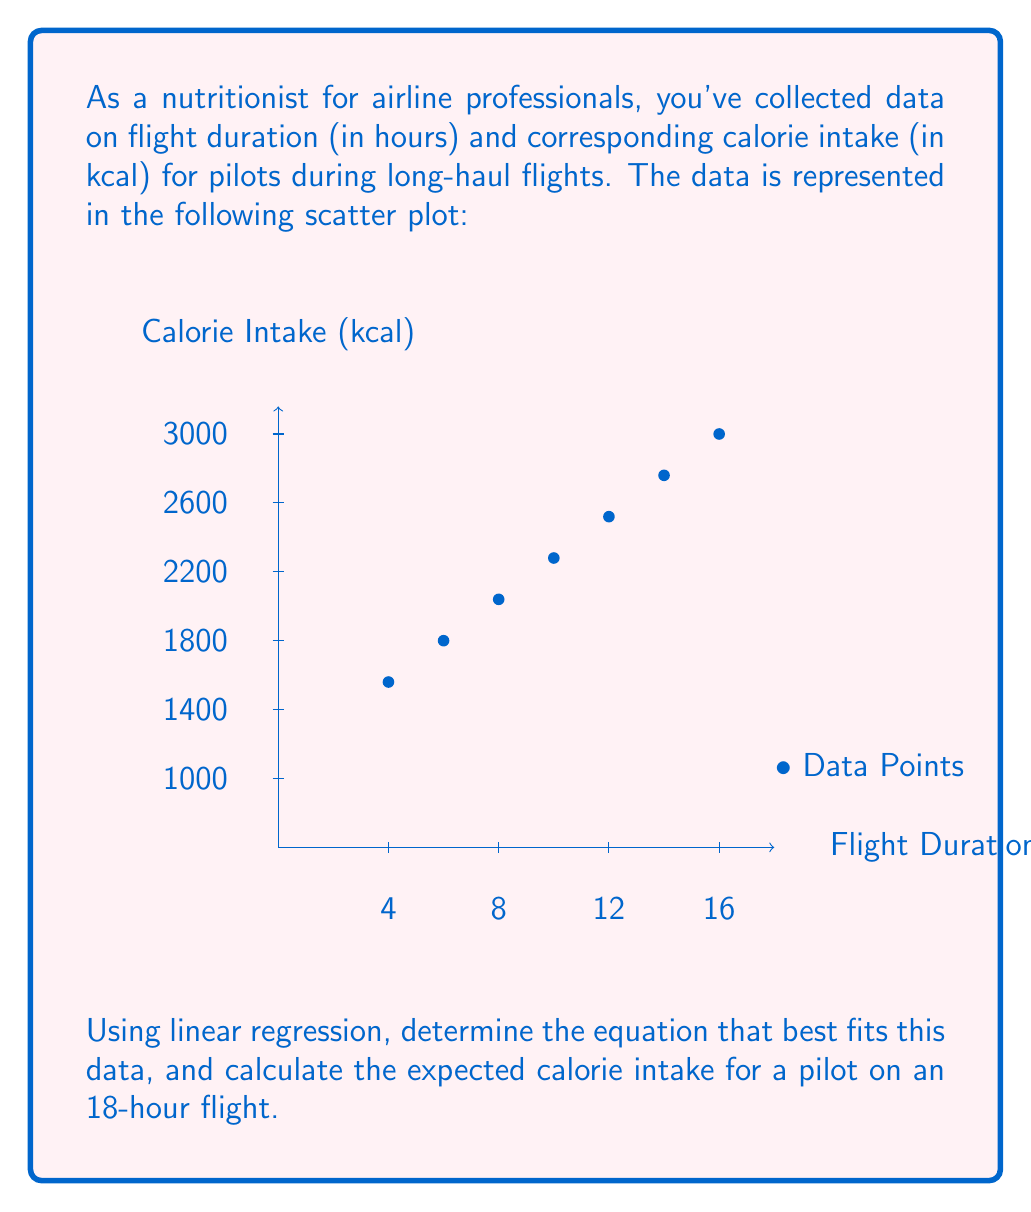Solve this math problem. To solve this problem, we'll use simple linear regression to find the best-fit line for the data.

Step 1: Calculate the means of x (flight duration) and y (calorie intake).
$\bar{x} = \frac{4+6+8+10+12+14+16}{7} = 10$
$\bar{y} = \frac{1200+1500+1800+2100+2400+2700+3000}{7} = 2100$

Step 2: Calculate the slope (m) using the formula:
$$m = \frac{\sum(x_i - \bar{x})(y_i - \bar{y})}{\sum(x_i - \bar{x})^2}$$

$\sum(x_i - \bar{x})(y_i - \bar{y}) = (-6)(-900) + (-4)(-600) + ... + (6)(900) = 25200$
$\sum(x_i - \bar{x})^2 = (-6)^2 + (-4)^2 + ... + (6)^2 = 168$

$m = \frac{25200}{168} = 150$

Step 3: Calculate the y-intercept (b) using the formula:
$$b = \bar{y} - m\bar{x}$$
$b = 2100 - 150(10) = 600$

Step 4: Write the equation of the best-fit line:
$y = mx + b$
$y = 150x + 600$

Step 5: Calculate the expected calorie intake for an 18-hour flight:
$y = 150(18) + 600 = 3300$

Therefore, the expected calorie intake for a pilot on an 18-hour flight is 3300 kcal.
Answer: $y = 150x + 600$; 3300 kcal 